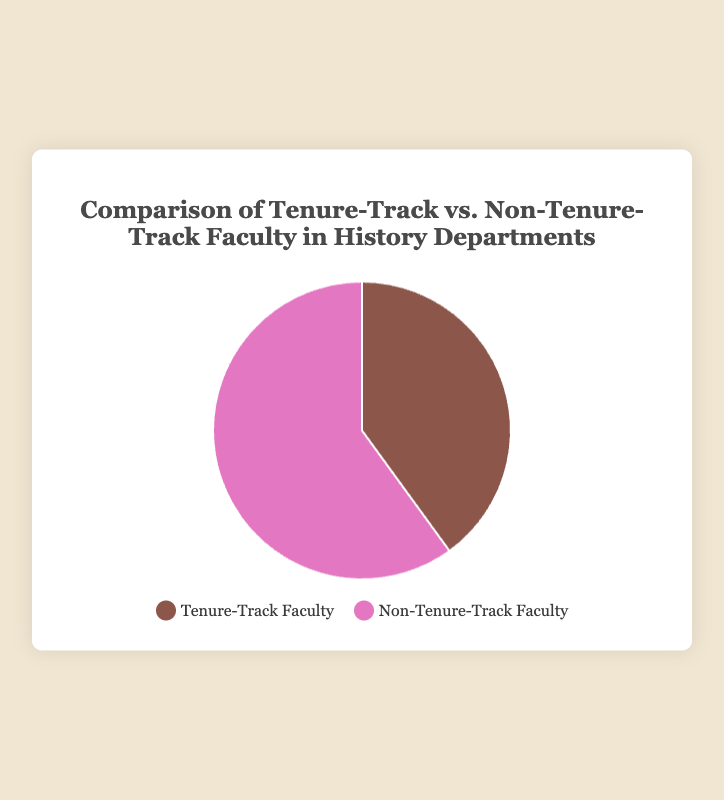What percentage of faculty in history departments are tenure-track? The pie chart shows a label for tenure-track faculty indicating a percentage.
Answer: 40% What percentage of faculty in history departments are non-tenure-track? The pie chart shows a label for non-tenure-track faculty indicating a percentage.
Answer: 60% Which group has a larger proportion of faculty members in history departments? Comparing the two segments of the pie chart, non-tenure-track faculty has a higher percentage.
Answer: Non-tenure-track faculty By how much percentage do non-tenure-track faculty exceed tenure-track faculty in history departments? The difference between the percentages can be calculated by subtracting the tenure-track faculty percentage from non-tenure-track faculty percentage: 60% - 40%.
Answer: 20% What visual colors represent tenure-track and non-tenure-track faculty in the pie chart? The legend and the pie chart show specific colors for each group. Tenure-track faculty are represented by brown, and non-tenure-track faculty are represented by pink.
Answer: Brown for tenure-track, Pink for non-tenure-track What is the total percentage covered by both faculty groups in the pie chart? The total percentage in a pie chart by definition sums up to 100%, combining both tenure-track (40%) and non-tenure-track (60%) faculty.
Answer: 100% If there were 200 faculty members in total, how many would be tenure-track? Calculate the number of tenure-track faculty by taking 40% of 200: (40/100) * 200.
Answer: 80 If there were 200 faculty members in total, how many would be non-tenure-track? Calculate the number of non-tenure-track faculty by taking 60% of 200: (60/100) * 200.
Answer: 120 What proportion does tenure-track faculty constitute compared to non-tenure-track faculty? The ratio of tenure-track to non-tenure-track can be expressed as 40:60, which simplifies to 2:3.
Answer: 2:3 How does the size of the segments representing tenure-track and non-tenure-track faculty compare? By observing the pie chart, the segment representing non-tenure-track faculty is larger than the segment for tenure-track faculty.
Answer: Non-tenure-track segment is larger 